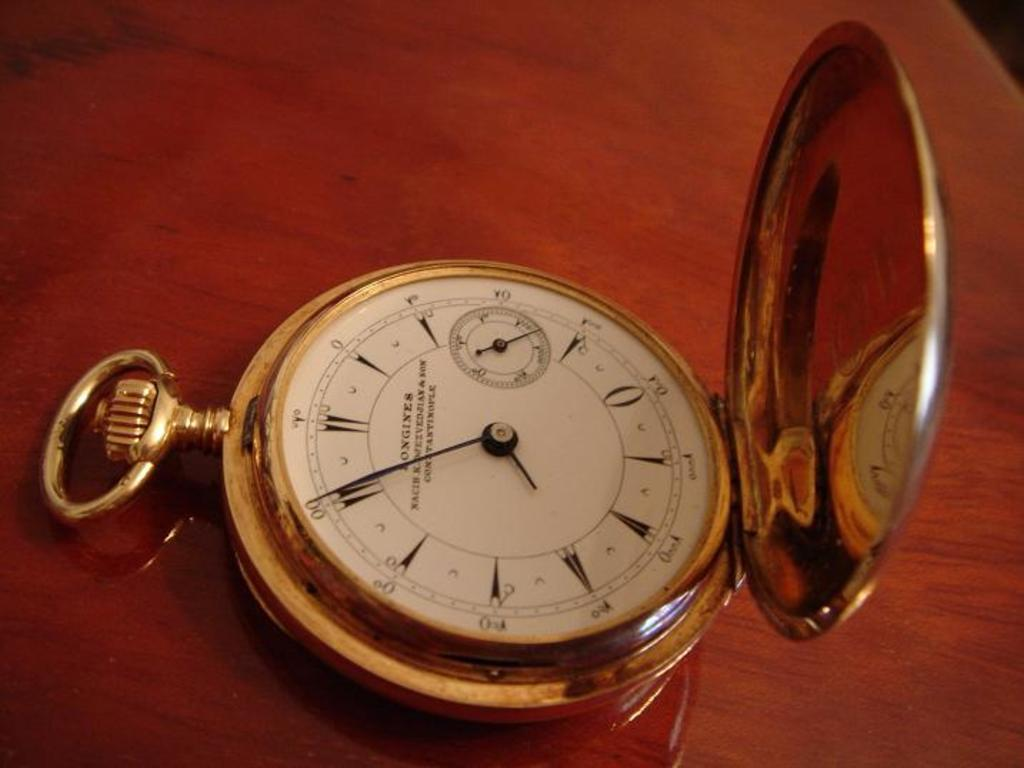<image>
Share a concise interpretation of the image provided. White and gold watch that has has the name "Longines" on the face. 